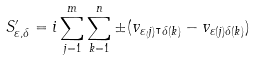<formula> <loc_0><loc_0><loc_500><loc_500>S ^ { \prime } _ { \varepsilon , \delta } = i \sum _ { j = 1 } ^ { m } \sum _ { k = 1 } ^ { n } \pm ( v _ { \varepsilon _ { ( } j ) ^ { \intercal } \delta ( k ) } - v _ { \varepsilon ( j ) \delta ( k ) } )</formula> 